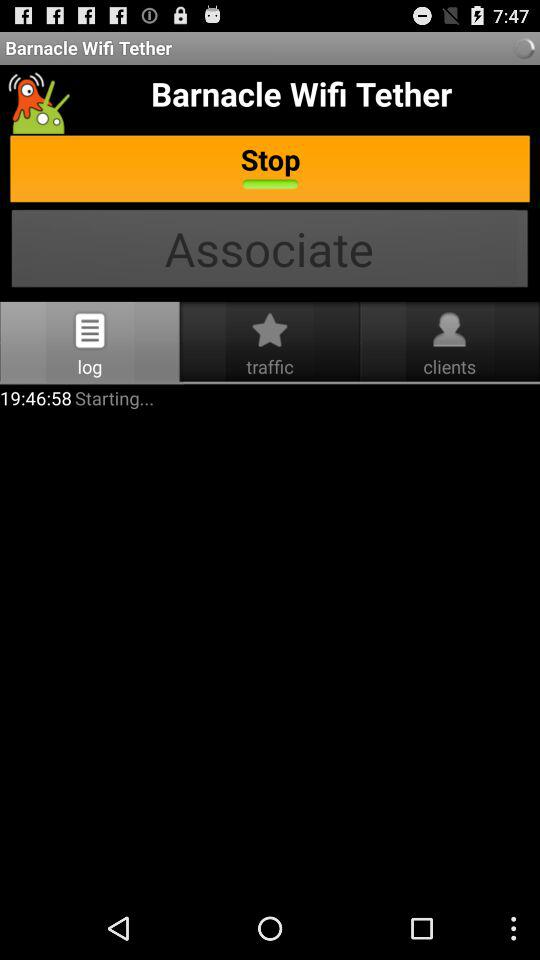What is the starting time? The starting time is 19:46:58. 